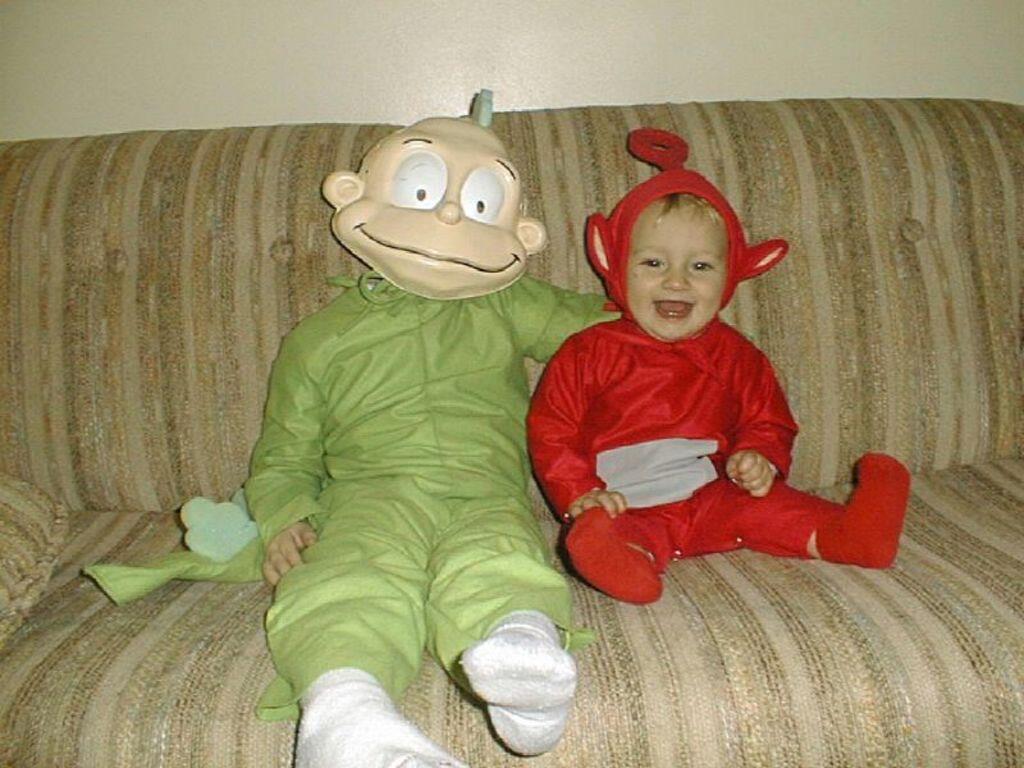In one or two sentences, can you explain what this image depicts? In this image I can see two people with green and red color dresses. I can see these people are sitting on the couch and one person wearing the mask. In the background I can see the wall. 